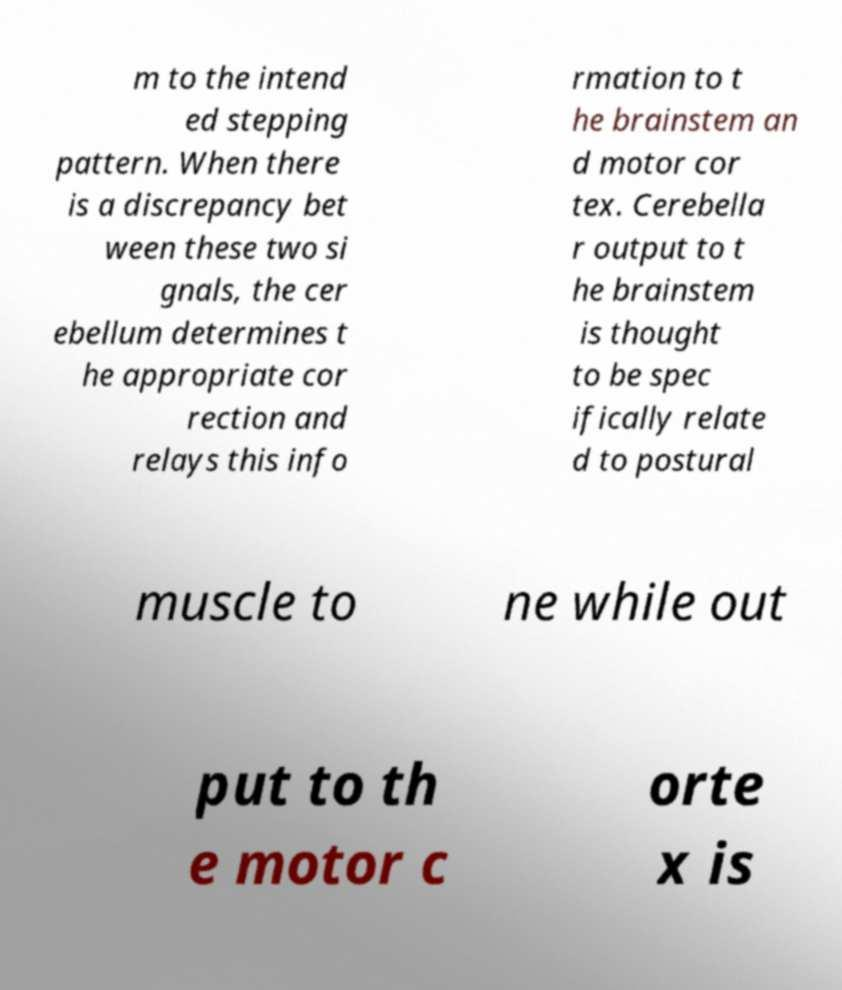There's text embedded in this image that I need extracted. Can you transcribe it verbatim? m to the intend ed stepping pattern. When there is a discrepancy bet ween these two si gnals, the cer ebellum determines t he appropriate cor rection and relays this info rmation to t he brainstem an d motor cor tex. Cerebella r output to t he brainstem is thought to be spec ifically relate d to postural muscle to ne while out put to th e motor c orte x is 